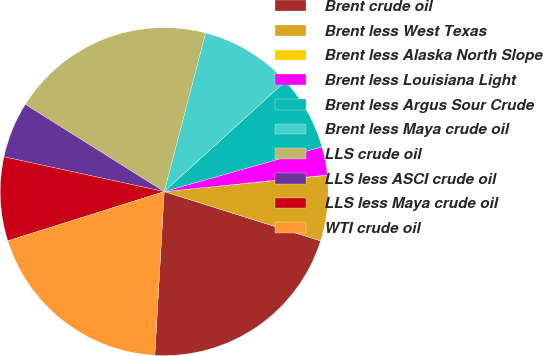Convert chart. <chart><loc_0><loc_0><loc_500><loc_500><pie_chart><fcel>Brent crude oil<fcel>Brent less West Texas<fcel>Brent less Alaska North Slope<fcel>Brent less Louisiana Light<fcel>Brent less Argus Sour Crude<fcel>Brent less Maya crude oil<fcel>LLS crude oil<fcel>LLS less ASCI crude oil<fcel>LLS less Maya crude oil<fcel>WTI crude oil<nl><fcel>21.05%<fcel>6.44%<fcel>0.04%<fcel>2.78%<fcel>7.35%<fcel>9.18%<fcel>20.14%<fcel>5.52%<fcel>8.26%<fcel>19.23%<nl></chart> 